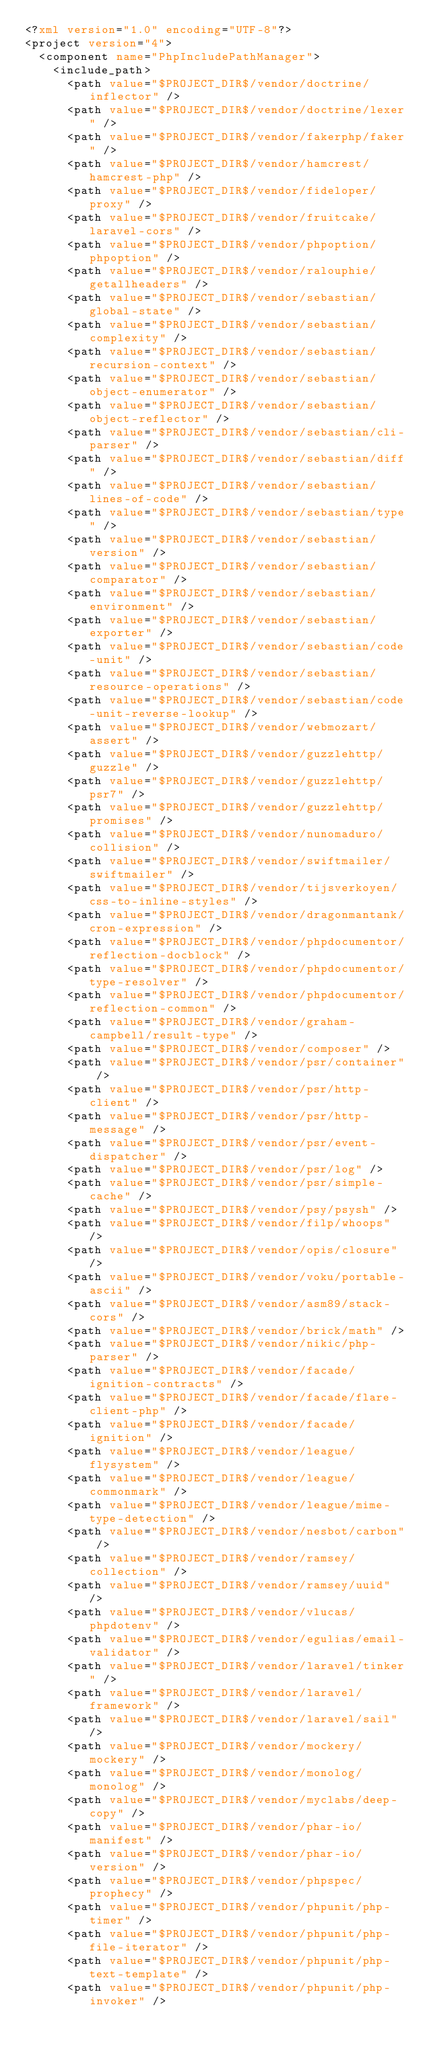Convert code to text. <code><loc_0><loc_0><loc_500><loc_500><_XML_><?xml version="1.0" encoding="UTF-8"?>
<project version="4">
  <component name="PhpIncludePathManager">
    <include_path>
      <path value="$PROJECT_DIR$/vendor/doctrine/inflector" />
      <path value="$PROJECT_DIR$/vendor/doctrine/lexer" />
      <path value="$PROJECT_DIR$/vendor/fakerphp/faker" />
      <path value="$PROJECT_DIR$/vendor/hamcrest/hamcrest-php" />
      <path value="$PROJECT_DIR$/vendor/fideloper/proxy" />
      <path value="$PROJECT_DIR$/vendor/fruitcake/laravel-cors" />
      <path value="$PROJECT_DIR$/vendor/phpoption/phpoption" />
      <path value="$PROJECT_DIR$/vendor/ralouphie/getallheaders" />
      <path value="$PROJECT_DIR$/vendor/sebastian/global-state" />
      <path value="$PROJECT_DIR$/vendor/sebastian/complexity" />
      <path value="$PROJECT_DIR$/vendor/sebastian/recursion-context" />
      <path value="$PROJECT_DIR$/vendor/sebastian/object-enumerator" />
      <path value="$PROJECT_DIR$/vendor/sebastian/object-reflector" />
      <path value="$PROJECT_DIR$/vendor/sebastian/cli-parser" />
      <path value="$PROJECT_DIR$/vendor/sebastian/diff" />
      <path value="$PROJECT_DIR$/vendor/sebastian/lines-of-code" />
      <path value="$PROJECT_DIR$/vendor/sebastian/type" />
      <path value="$PROJECT_DIR$/vendor/sebastian/version" />
      <path value="$PROJECT_DIR$/vendor/sebastian/comparator" />
      <path value="$PROJECT_DIR$/vendor/sebastian/environment" />
      <path value="$PROJECT_DIR$/vendor/sebastian/exporter" />
      <path value="$PROJECT_DIR$/vendor/sebastian/code-unit" />
      <path value="$PROJECT_DIR$/vendor/sebastian/resource-operations" />
      <path value="$PROJECT_DIR$/vendor/sebastian/code-unit-reverse-lookup" />
      <path value="$PROJECT_DIR$/vendor/webmozart/assert" />
      <path value="$PROJECT_DIR$/vendor/guzzlehttp/guzzle" />
      <path value="$PROJECT_DIR$/vendor/guzzlehttp/psr7" />
      <path value="$PROJECT_DIR$/vendor/guzzlehttp/promises" />
      <path value="$PROJECT_DIR$/vendor/nunomaduro/collision" />
      <path value="$PROJECT_DIR$/vendor/swiftmailer/swiftmailer" />
      <path value="$PROJECT_DIR$/vendor/tijsverkoyen/css-to-inline-styles" />
      <path value="$PROJECT_DIR$/vendor/dragonmantank/cron-expression" />
      <path value="$PROJECT_DIR$/vendor/phpdocumentor/reflection-docblock" />
      <path value="$PROJECT_DIR$/vendor/phpdocumentor/type-resolver" />
      <path value="$PROJECT_DIR$/vendor/phpdocumentor/reflection-common" />
      <path value="$PROJECT_DIR$/vendor/graham-campbell/result-type" />
      <path value="$PROJECT_DIR$/vendor/composer" />
      <path value="$PROJECT_DIR$/vendor/psr/container" />
      <path value="$PROJECT_DIR$/vendor/psr/http-client" />
      <path value="$PROJECT_DIR$/vendor/psr/http-message" />
      <path value="$PROJECT_DIR$/vendor/psr/event-dispatcher" />
      <path value="$PROJECT_DIR$/vendor/psr/log" />
      <path value="$PROJECT_DIR$/vendor/psr/simple-cache" />
      <path value="$PROJECT_DIR$/vendor/psy/psysh" />
      <path value="$PROJECT_DIR$/vendor/filp/whoops" />
      <path value="$PROJECT_DIR$/vendor/opis/closure" />
      <path value="$PROJECT_DIR$/vendor/voku/portable-ascii" />
      <path value="$PROJECT_DIR$/vendor/asm89/stack-cors" />
      <path value="$PROJECT_DIR$/vendor/brick/math" />
      <path value="$PROJECT_DIR$/vendor/nikic/php-parser" />
      <path value="$PROJECT_DIR$/vendor/facade/ignition-contracts" />
      <path value="$PROJECT_DIR$/vendor/facade/flare-client-php" />
      <path value="$PROJECT_DIR$/vendor/facade/ignition" />
      <path value="$PROJECT_DIR$/vendor/league/flysystem" />
      <path value="$PROJECT_DIR$/vendor/league/commonmark" />
      <path value="$PROJECT_DIR$/vendor/league/mime-type-detection" />
      <path value="$PROJECT_DIR$/vendor/nesbot/carbon" />
      <path value="$PROJECT_DIR$/vendor/ramsey/collection" />
      <path value="$PROJECT_DIR$/vendor/ramsey/uuid" />
      <path value="$PROJECT_DIR$/vendor/vlucas/phpdotenv" />
      <path value="$PROJECT_DIR$/vendor/egulias/email-validator" />
      <path value="$PROJECT_DIR$/vendor/laravel/tinker" />
      <path value="$PROJECT_DIR$/vendor/laravel/framework" />
      <path value="$PROJECT_DIR$/vendor/laravel/sail" />
      <path value="$PROJECT_DIR$/vendor/mockery/mockery" />
      <path value="$PROJECT_DIR$/vendor/monolog/monolog" />
      <path value="$PROJECT_DIR$/vendor/myclabs/deep-copy" />
      <path value="$PROJECT_DIR$/vendor/phar-io/manifest" />
      <path value="$PROJECT_DIR$/vendor/phar-io/version" />
      <path value="$PROJECT_DIR$/vendor/phpspec/prophecy" />
      <path value="$PROJECT_DIR$/vendor/phpunit/php-timer" />
      <path value="$PROJECT_DIR$/vendor/phpunit/php-file-iterator" />
      <path value="$PROJECT_DIR$/vendor/phpunit/php-text-template" />
      <path value="$PROJECT_DIR$/vendor/phpunit/php-invoker" /></code> 